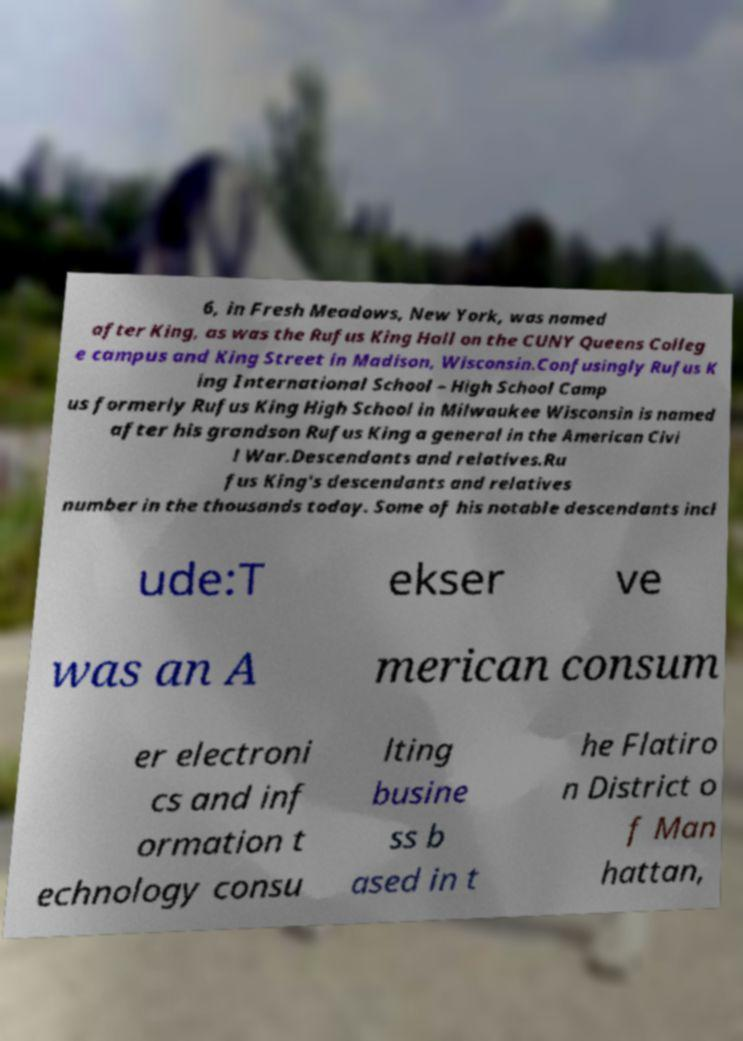Can you read and provide the text displayed in the image?This photo seems to have some interesting text. Can you extract and type it out for me? 6, in Fresh Meadows, New York, was named after King, as was the Rufus King Hall on the CUNY Queens Colleg e campus and King Street in Madison, Wisconsin.Confusingly Rufus K ing International School – High School Camp us formerly Rufus King High School in Milwaukee Wisconsin is named after his grandson Rufus King a general in the American Civi l War.Descendants and relatives.Ru fus King's descendants and relatives number in the thousands today. Some of his notable descendants incl ude:T ekser ve was an A merican consum er electroni cs and inf ormation t echnology consu lting busine ss b ased in t he Flatiro n District o f Man hattan, 